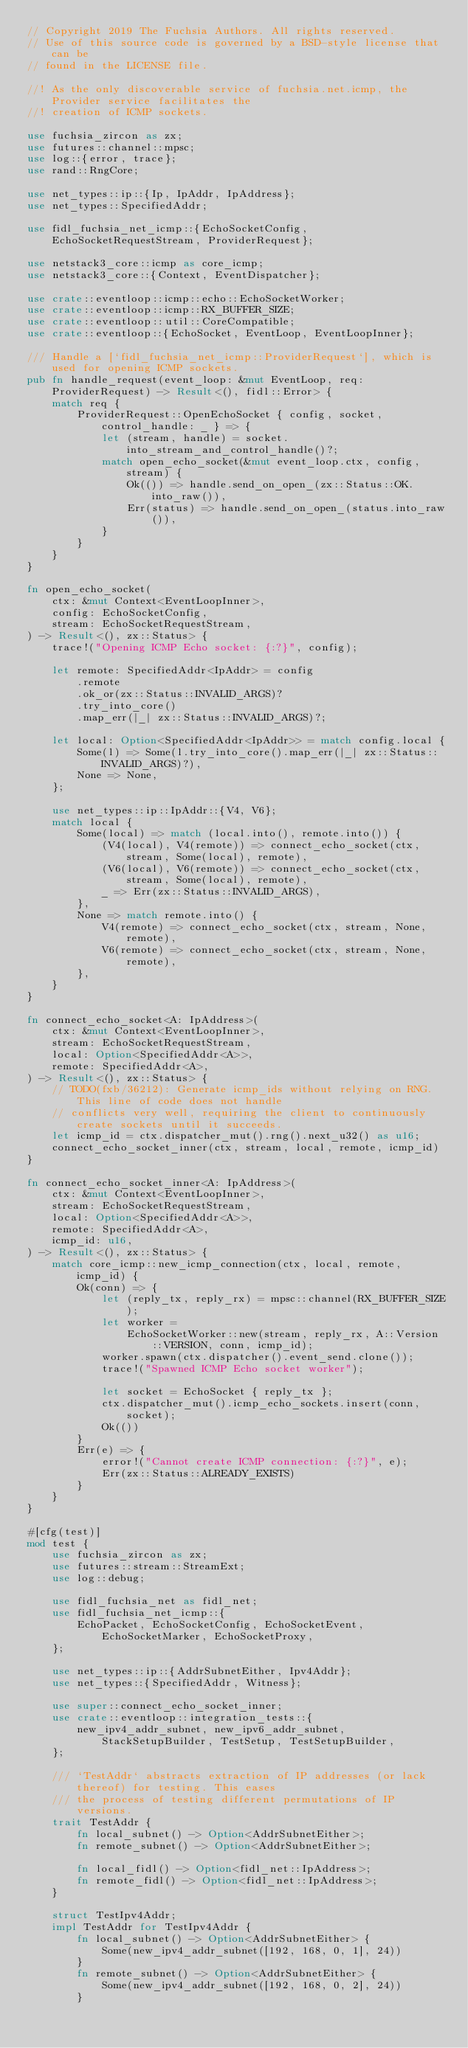<code> <loc_0><loc_0><loc_500><loc_500><_Rust_>// Copyright 2019 The Fuchsia Authors. All rights reserved.
// Use of this source code is governed by a BSD-style license that can be
// found in the LICENSE file.

//! As the only discoverable service of fuchsia.net.icmp, the Provider service facilitates the
//! creation of ICMP sockets.

use fuchsia_zircon as zx;
use futures::channel::mpsc;
use log::{error, trace};
use rand::RngCore;

use net_types::ip::{Ip, IpAddr, IpAddress};
use net_types::SpecifiedAddr;

use fidl_fuchsia_net_icmp::{EchoSocketConfig, EchoSocketRequestStream, ProviderRequest};

use netstack3_core::icmp as core_icmp;
use netstack3_core::{Context, EventDispatcher};

use crate::eventloop::icmp::echo::EchoSocketWorker;
use crate::eventloop::icmp::RX_BUFFER_SIZE;
use crate::eventloop::util::CoreCompatible;
use crate::eventloop::{EchoSocket, EventLoop, EventLoopInner};

/// Handle a [`fidl_fuchsia_net_icmp::ProviderRequest`], which is used for opening ICMP sockets.
pub fn handle_request(event_loop: &mut EventLoop, req: ProviderRequest) -> Result<(), fidl::Error> {
    match req {
        ProviderRequest::OpenEchoSocket { config, socket, control_handle: _ } => {
            let (stream, handle) = socket.into_stream_and_control_handle()?;
            match open_echo_socket(&mut event_loop.ctx, config, stream) {
                Ok(()) => handle.send_on_open_(zx::Status::OK.into_raw()),
                Err(status) => handle.send_on_open_(status.into_raw()),
            }
        }
    }
}

fn open_echo_socket(
    ctx: &mut Context<EventLoopInner>,
    config: EchoSocketConfig,
    stream: EchoSocketRequestStream,
) -> Result<(), zx::Status> {
    trace!("Opening ICMP Echo socket: {:?}", config);

    let remote: SpecifiedAddr<IpAddr> = config
        .remote
        .ok_or(zx::Status::INVALID_ARGS)?
        .try_into_core()
        .map_err(|_| zx::Status::INVALID_ARGS)?;

    let local: Option<SpecifiedAddr<IpAddr>> = match config.local {
        Some(l) => Some(l.try_into_core().map_err(|_| zx::Status::INVALID_ARGS)?),
        None => None,
    };

    use net_types::ip::IpAddr::{V4, V6};
    match local {
        Some(local) => match (local.into(), remote.into()) {
            (V4(local), V4(remote)) => connect_echo_socket(ctx, stream, Some(local), remote),
            (V6(local), V6(remote)) => connect_echo_socket(ctx, stream, Some(local), remote),
            _ => Err(zx::Status::INVALID_ARGS),
        },
        None => match remote.into() {
            V4(remote) => connect_echo_socket(ctx, stream, None, remote),
            V6(remote) => connect_echo_socket(ctx, stream, None, remote),
        },
    }
}

fn connect_echo_socket<A: IpAddress>(
    ctx: &mut Context<EventLoopInner>,
    stream: EchoSocketRequestStream,
    local: Option<SpecifiedAddr<A>>,
    remote: SpecifiedAddr<A>,
) -> Result<(), zx::Status> {
    // TODO(fxb/36212): Generate icmp_ids without relying on RNG. This line of code does not handle
    // conflicts very well, requiring the client to continuously create sockets until it succeeds.
    let icmp_id = ctx.dispatcher_mut().rng().next_u32() as u16;
    connect_echo_socket_inner(ctx, stream, local, remote, icmp_id)
}

fn connect_echo_socket_inner<A: IpAddress>(
    ctx: &mut Context<EventLoopInner>,
    stream: EchoSocketRequestStream,
    local: Option<SpecifiedAddr<A>>,
    remote: SpecifiedAddr<A>,
    icmp_id: u16,
) -> Result<(), zx::Status> {
    match core_icmp::new_icmp_connection(ctx, local, remote, icmp_id) {
        Ok(conn) => {
            let (reply_tx, reply_rx) = mpsc::channel(RX_BUFFER_SIZE);
            let worker =
                EchoSocketWorker::new(stream, reply_rx, A::Version::VERSION, conn, icmp_id);
            worker.spawn(ctx.dispatcher().event_send.clone());
            trace!("Spawned ICMP Echo socket worker");

            let socket = EchoSocket { reply_tx };
            ctx.dispatcher_mut().icmp_echo_sockets.insert(conn, socket);
            Ok(())
        }
        Err(e) => {
            error!("Cannot create ICMP connection: {:?}", e);
            Err(zx::Status::ALREADY_EXISTS)
        }
    }
}

#[cfg(test)]
mod test {
    use fuchsia_zircon as zx;
    use futures::stream::StreamExt;
    use log::debug;

    use fidl_fuchsia_net as fidl_net;
    use fidl_fuchsia_net_icmp::{
        EchoPacket, EchoSocketConfig, EchoSocketEvent, EchoSocketMarker, EchoSocketProxy,
    };

    use net_types::ip::{AddrSubnetEither, Ipv4Addr};
    use net_types::{SpecifiedAddr, Witness};

    use super::connect_echo_socket_inner;
    use crate::eventloop::integration_tests::{
        new_ipv4_addr_subnet, new_ipv6_addr_subnet, StackSetupBuilder, TestSetup, TestSetupBuilder,
    };

    /// `TestAddr` abstracts extraction of IP addresses (or lack thereof) for testing. This eases
    /// the process of testing different permutations of IP versions.
    trait TestAddr {
        fn local_subnet() -> Option<AddrSubnetEither>;
        fn remote_subnet() -> Option<AddrSubnetEither>;

        fn local_fidl() -> Option<fidl_net::IpAddress>;
        fn remote_fidl() -> Option<fidl_net::IpAddress>;
    }

    struct TestIpv4Addr;
    impl TestAddr for TestIpv4Addr {
        fn local_subnet() -> Option<AddrSubnetEither> {
            Some(new_ipv4_addr_subnet([192, 168, 0, 1], 24))
        }
        fn remote_subnet() -> Option<AddrSubnetEither> {
            Some(new_ipv4_addr_subnet([192, 168, 0, 2], 24))
        }
</code> 